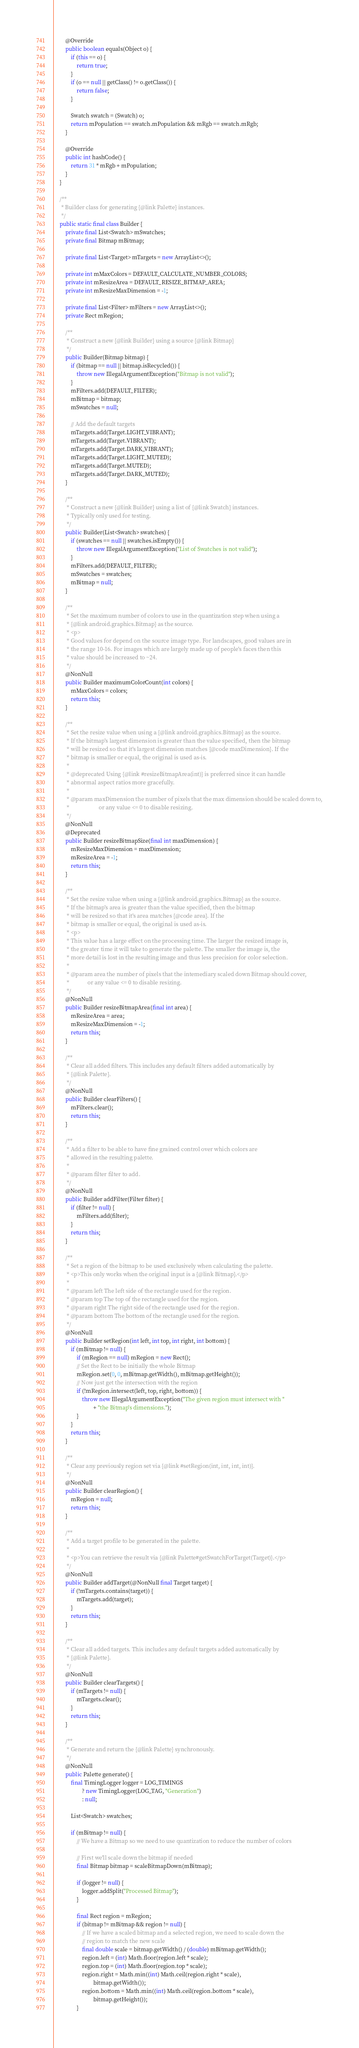Convert code to text. <code><loc_0><loc_0><loc_500><loc_500><_Java_>        @Override
        public boolean equals(Object o) {
            if (this == o) {
                return true;
            }
            if (o == null || getClass() != o.getClass()) {
                return false;
            }

            Swatch swatch = (Swatch) o;
            return mPopulation == swatch.mPopulation && mRgb == swatch.mRgb;
        }

        @Override
        public int hashCode() {
            return 31 * mRgb + mPopulation;
        }
    }

    /**
     * Builder class for generating {@link Palette} instances.
     */
    public static final class Builder {
        private final List<Swatch> mSwatches;
        private final Bitmap mBitmap;

        private final List<Target> mTargets = new ArrayList<>();

        private int mMaxColors = DEFAULT_CALCULATE_NUMBER_COLORS;
        private int mResizeArea = DEFAULT_RESIZE_BITMAP_AREA;
        private int mResizeMaxDimension = -1;

        private final List<Filter> mFilters = new ArrayList<>();
        private Rect mRegion;

        /**
         * Construct a new {@link Builder} using a source {@link Bitmap}
         */
        public Builder(Bitmap bitmap) {
            if (bitmap == null || bitmap.isRecycled()) {
                throw new IllegalArgumentException("Bitmap is not valid");
            }
            mFilters.add(DEFAULT_FILTER);
            mBitmap = bitmap;
            mSwatches = null;

            // Add the default targets
            mTargets.add(Target.LIGHT_VIBRANT);
            mTargets.add(Target.VIBRANT);
            mTargets.add(Target.DARK_VIBRANT);
            mTargets.add(Target.LIGHT_MUTED);
            mTargets.add(Target.MUTED);
            mTargets.add(Target.DARK_MUTED);
        }

        /**
         * Construct a new {@link Builder} using a list of {@link Swatch} instances.
         * Typically only used for testing.
         */
        public Builder(List<Swatch> swatches) {
            if (swatches == null || swatches.isEmpty()) {
                throw new IllegalArgumentException("List of Swatches is not valid");
            }
            mFilters.add(DEFAULT_FILTER);
            mSwatches = swatches;
            mBitmap = null;
        }

        /**
         * Set the maximum number of colors to use in the quantization step when using a
         * {@link android.graphics.Bitmap} as the source.
         * <p>
         * Good values for depend on the source image type. For landscapes, good values are in
         * the range 10-16. For images which are largely made up of people's faces then this
         * value should be increased to ~24.
         */
        @NonNull
        public Builder maximumColorCount(int colors) {
            mMaxColors = colors;
            return this;
        }

        /**
         * Set the resize value when using a {@link android.graphics.Bitmap} as the source.
         * If the bitmap's largest dimension is greater than the value specified, then the bitmap
         * will be resized so that it's largest dimension matches {@code maxDimension}. If the
         * bitmap is smaller or equal, the original is used as-is.
         *
         * @deprecated Using {@link #resizeBitmapArea(int)} is preferred since it can handle
         * abnormal aspect ratios more gracefully.
         *
         * @param maxDimension the number of pixels that the max dimension should be scaled down to,
         *                     or any value <= 0 to disable resizing.
         */
        @NonNull
        @Deprecated
        public Builder resizeBitmapSize(final int maxDimension) {
            mResizeMaxDimension = maxDimension;
            mResizeArea = -1;
            return this;
        }

        /**
         * Set the resize value when using a {@link android.graphics.Bitmap} as the source.
         * If the bitmap's area is greater than the value specified, then the bitmap
         * will be resized so that it's area matches {@code area}. If the
         * bitmap is smaller or equal, the original is used as-is.
         * <p>
         * This value has a large effect on the processing time. The larger the resized image is,
         * the greater time it will take to generate the palette. The smaller the image is, the
         * more detail is lost in the resulting image and thus less precision for color selection.
         *
         * @param area the number of pixels that the intemediary scaled down Bitmap should cover,
         *             or any value <= 0 to disable resizing.
         */
        @NonNull
        public Builder resizeBitmapArea(final int area) {
            mResizeArea = area;
            mResizeMaxDimension = -1;
            return this;
        }

        /**
         * Clear all added filters. This includes any default filters added automatically by
         * {@link Palette}.
         */
        @NonNull
        public Builder clearFilters() {
            mFilters.clear();
            return this;
        }

        /**
         * Add a filter to be able to have fine grained control over which colors are
         * allowed in the resulting palette.
         *
         * @param filter filter to add.
         */
        @NonNull
        public Builder addFilter(Filter filter) {
            if (filter != null) {
                mFilters.add(filter);
            }
            return this;
        }

        /**
         * Set a region of the bitmap to be used exclusively when calculating the palette.
         * <p>This only works when the original input is a {@link Bitmap}.</p>
         *
         * @param left The left side of the rectangle used for the region.
         * @param top The top of the rectangle used for the region.
         * @param right The right side of the rectangle used for the region.
         * @param bottom The bottom of the rectangle used for the region.
         */
        @NonNull
        public Builder setRegion(int left, int top, int right, int bottom) {
            if (mBitmap != null) {
                if (mRegion == null) mRegion = new Rect();
                // Set the Rect to be initially the whole Bitmap
                mRegion.set(0, 0, mBitmap.getWidth(), mBitmap.getHeight());
                // Now just get the intersection with the region
                if (!mRegion.intersect(left, top, right, bottom)) {
                    throw new IllegalArgumentException("The given region must intersect with "
                            + "the Bitmap's dimensions.");
                }
            }
            return this;
        }

        /**
         * Clear any previously region set via {@link #setRegion(int, int, int, int)}.
         */
        @NonNull
        public Builder clearRegion() {
            mRegion = null;
            return this;
        }

        /**
         * Add a target profile to be generated in the palette.
         *
         * <p>You can retrieve the result via {@link Palette#getSwatchForTarget(Target)}.</p>
         */
        @NonNull
        public Builder addTarget(@NonNull final Target target) {
            if (!mTargets.contains(target)) {
                mTargets.add(target);
            }
            return this;
        }

        /**
         * Clear all added targets. This includes any default targets added automatically by
         * {@link Palette}.
         */
        @NonNull
        public Builder clearTargets() {
            if (mTargets != null) {
                mTargets.clear();
            }
            return this;
        }

        /**
         * Generate and return the {@link Palette} synchronously.
         */
        @NonNull
        public Palette generate() {
            final TimingLogger logger = LOG_TIMINGS
                    ? new TimingLogger(LOG_TAG, "Generation")
                    : null;

            List<Swatch> swatches;

            if (mBitmap != null) {
                // We have a Bitmap so we need to use quantization to reduce the number of colors

                // First we'll scale down the bitmap if needed
                final Bitmap bitmap = scaleBitmapDown(mBitmap);

                if (logger != null) {
                    logger.addSplit("Processed Bitmap");
                }

                final Rect region = mRegion;
                if (bitmap != mBitmap && region != null) {
                    // If we have a scaled bitmap and a selected region, we need to scale down the
                    // region to match the new scale
                    final double scale = bitmap.getWidth() / (double) mBitmap.getWidth();
                    region.left = (int) Math.floor(region.left * scale);
                    region.top = (int) Math.floor(region.top * scale);
                    region.right = Math.min((int) Math.ceil(region.right * scale),
                            bitmap.getWidth());
                    region.bottom = Math.min((int) Math.ceil(region.bottom * scale),
                            bitmap.getHeight());
                }
</code> 